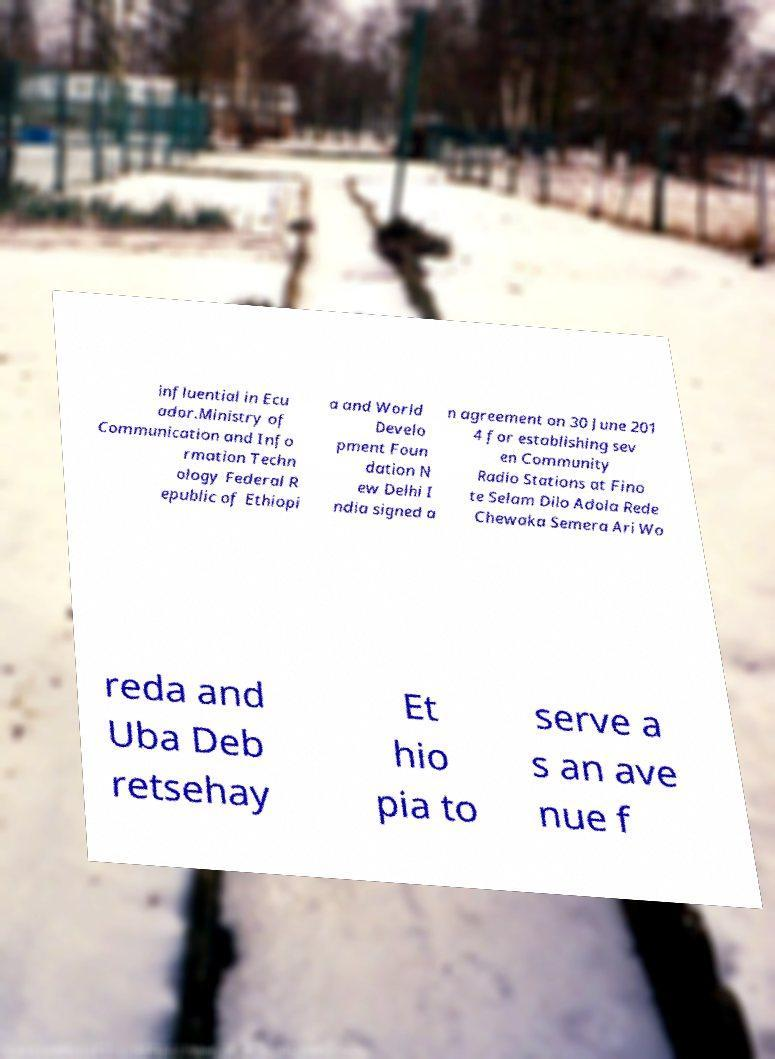There's text embedded in this image that I need extracted. Can you transcribe it verbatim? influential in Ecu ador.Ministry of Communication and Info rmation Techn ology Federal R epublic of Ethiopi a and World Develo pment Foun dation N ew Delhi I ndia signed a n agreement on 30 June 201 4 for establishing sev en Community Radio Stations at Fino te Selam Dilo Adola Rede Chewaka Semera Ari Wo reda and Uba Deb retsehay Et hio pia to serve a s an ave nue f 